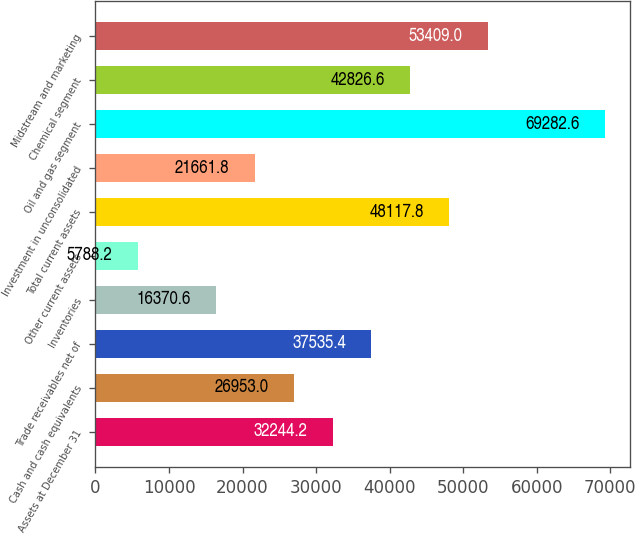<chart> <loc_0><loc_0><loc_500><loc_500><bar_chart><fcel>Assets at December 31<fcel>Cash and cash equivalents<fcel>Trade receivables net of<fcel>Inventories<fcel>Other current assets<fcel>Total current assets<fcel>Investment in unconsolidated<fcel>Oil and gas segment<fcel>Chemical segment<fcel>Midstream and marketing<nl><fcel>32244.2<fcel>26953<fcel>37535.4<fcel>16370.6<fcel>5788.2<fcel>48117.8<fcel>21661.8<fcel>69282.6<fcel>42826.6<fcel>53409<nl></chart> 